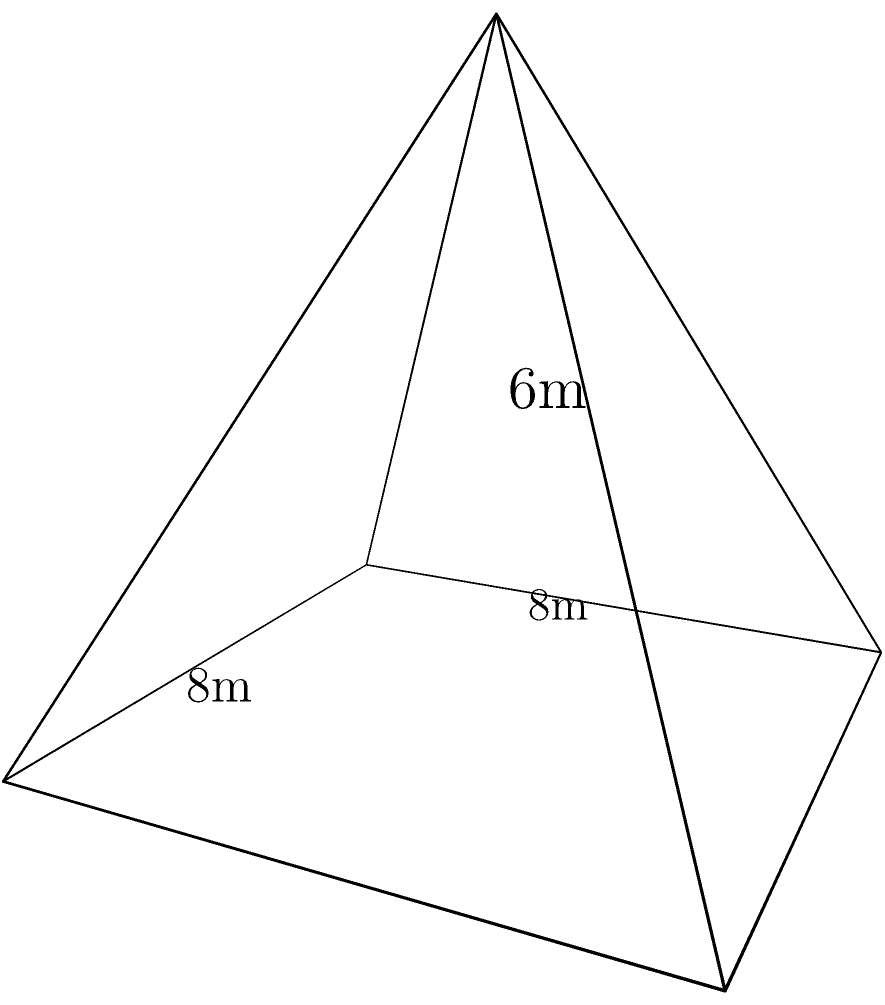In your latest adventure novel, the protagonist discovers an ancient Egyptian tomb shaped like a perfect square pyramid. The base of the pyramid measures 8 meters on each side, and its height is 6 meters. To create tension in the story, you need to calculate the surface area of the tomb, as it's crucial for a puzzle your character must solve. What is the total surface area of the pyramid-shaped tomb, including its base? Let's approach this step-by-step:

1) First, we need to calculate the area of the base:
   Base area = $8m \times 8m = 64m^2$

2) Next, we need to find the slant height of the pyramid. We can do this using the Pythagorean theorem:
   Let $s$ be the slant height.
   $s^2 = (\frac{8}{2})^2 + 6^2$
   $s^2 = 4^2 + 6^2 = 16 + 36 = 52$
   $s = \sqrt{52} = 2\sqrt{13}$ meters

3) Now we can calculate the area of one triangular face:
   Area of one face = $\frac{1}{2} \times 8 \times 2\sqrt{13} = 4\sqrt{13}$ $m^2$

4) There are four identical triangular faces, so:
   Total area of slanted surfaces = $4 \times 4\sqrt{13} = 16\sqrt{13}$ $m^2$

5) The total surface area is the sum of the base area and the area of all four triangular faces:
   Total surface area = $64 + 16\sqrt{13}$ $m^2$

This result provides an intriguing number for your protagonist to work with in solving the tomb's puzzle.
Answer: $64 + 16\sqrt{13}$ $m^2$ 